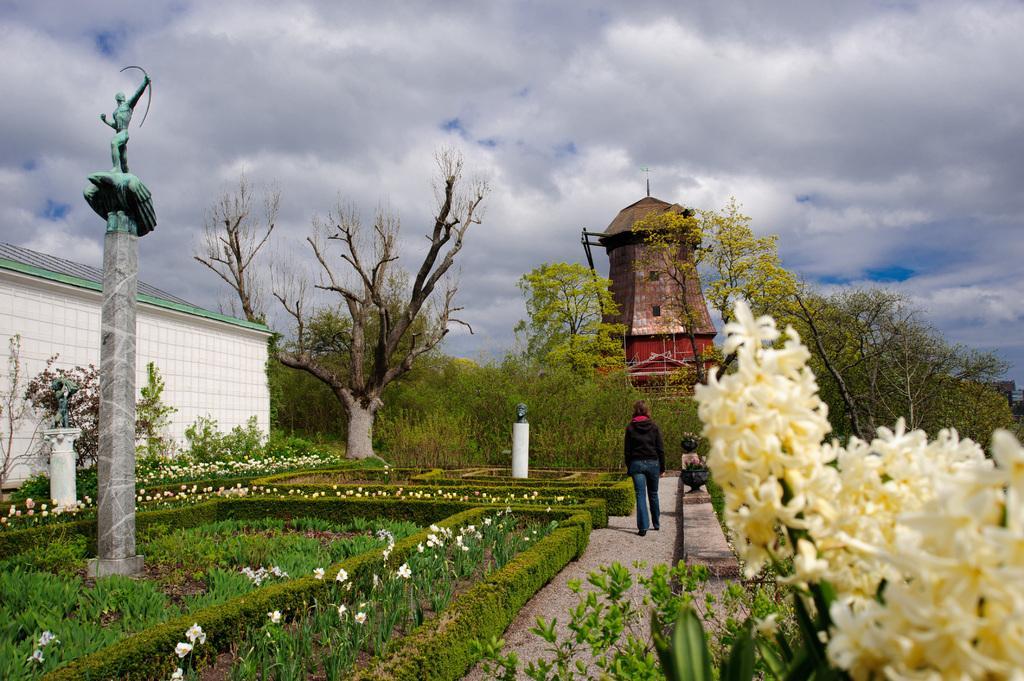How would you summarize this image in a sentence or two? In this picture we can see a person is walking on the path and on the right side of the person there are trees. On the left side of the person there is a statue on a pillar, house, bushes and other things. In front of the people there is a tower and a cloudy sky. 